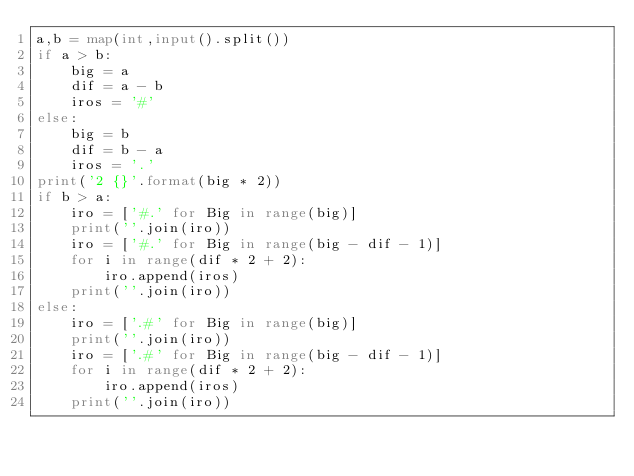Convert code to text. <code><loc_0><loc_0><loc_500><loc_500><_Python_>a,b = map(int,input().split())
if a > b:
    big = a
    dif = a - b
    iros = '#'
else:
    big = b
    dif = b - a
    iros = '.'
print('2 {}'.format(big * 2))
if b > a:
    iro = ['#.' for Big in range(big)]
    print(''.join(iro))
    iro = ['#.' for Big in range(big - dif - 1)]
    for i in range(dif * 2 + 2):
        iro.append(iros)
    print(''.join(iro))
else:
    iro = ['.#' for Big in range(big)]
    print(''.join(iro))
    iro = ['.#' for Big in range(big - dif - 1)]
    for i in range(dif * 2 + 2):
        iro.append(iros)
    print(''.join(iro))</code> 